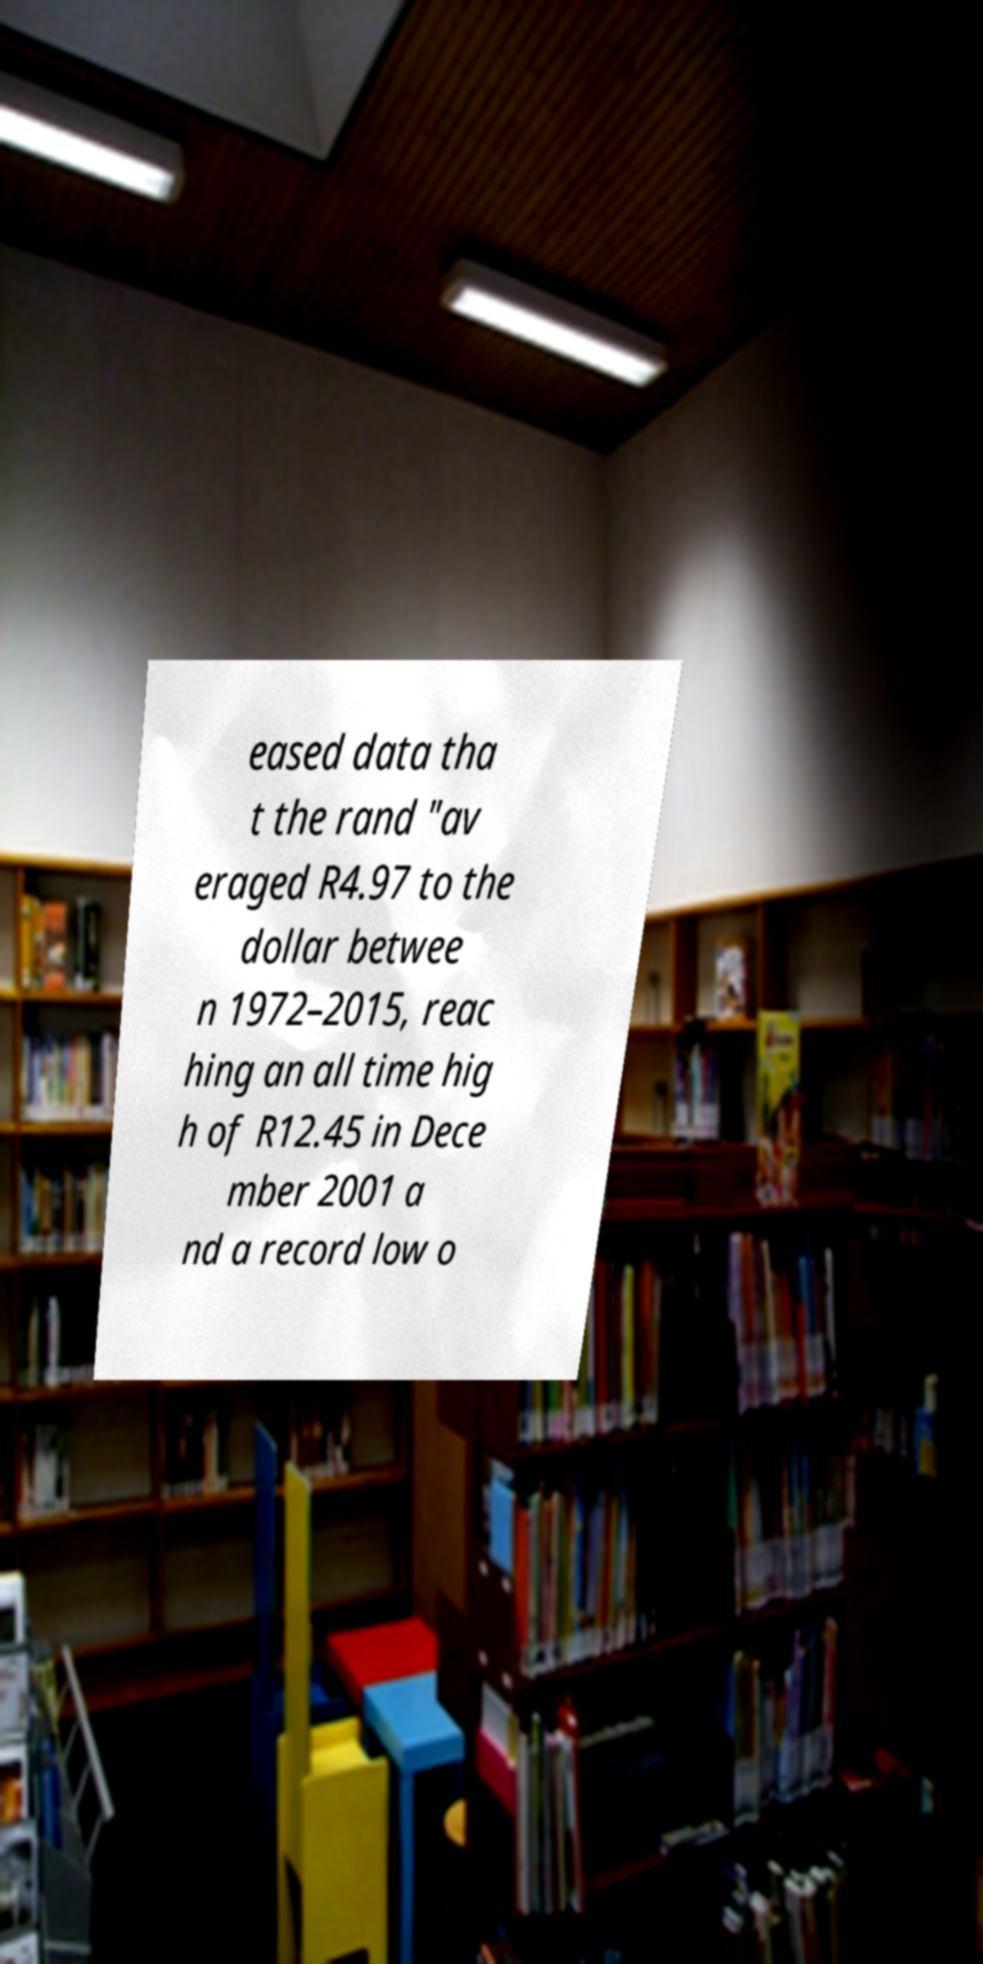For documentation purposes, I need the text within this image transcribed. Could you provide that? eased data tha t the rand "av eraged R4.97 to the dollar betwee n 1972–2015, reac hing an all time hig h of R12.45 in Dece mber 2001 a nd a record low o 